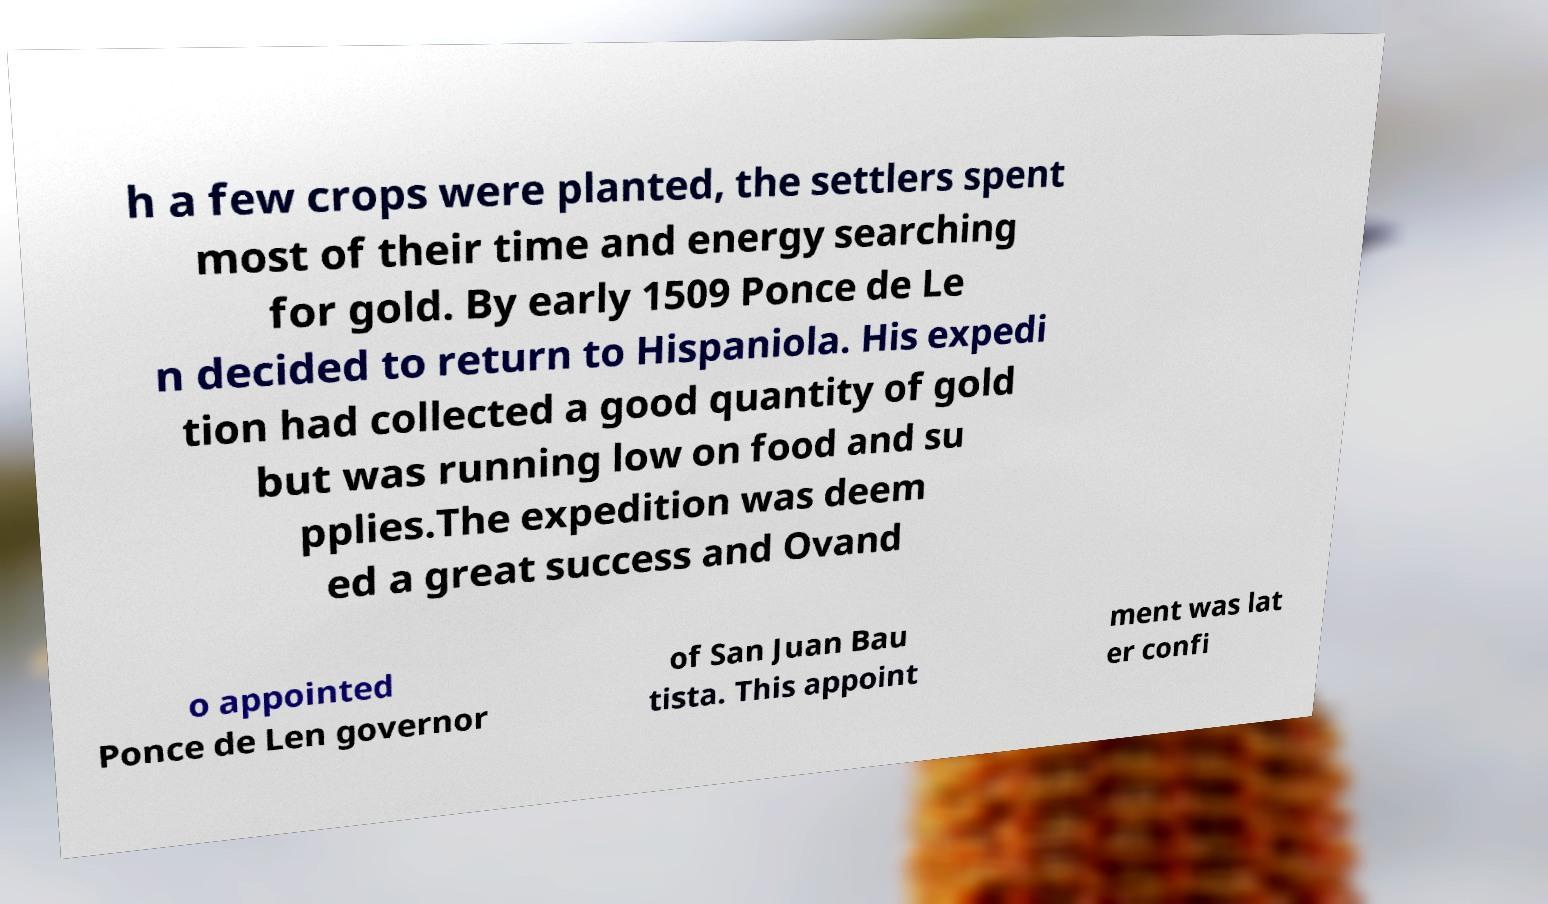Could you assist in decoding the text presented in this image and type it out clearly? h a few crops were planted, the settlers spent most of their time and energy searching for gold. By early 1509 Ponce de Le n decided to return to Hispaniola. His expedi tion had collected a good quantity of gold but was running low on food and su pplies.The expedition was deem ed a great success and Ovand o appointed Ponce de Len governor of San Juan Bau tista. This appoint ment was lat er confi 